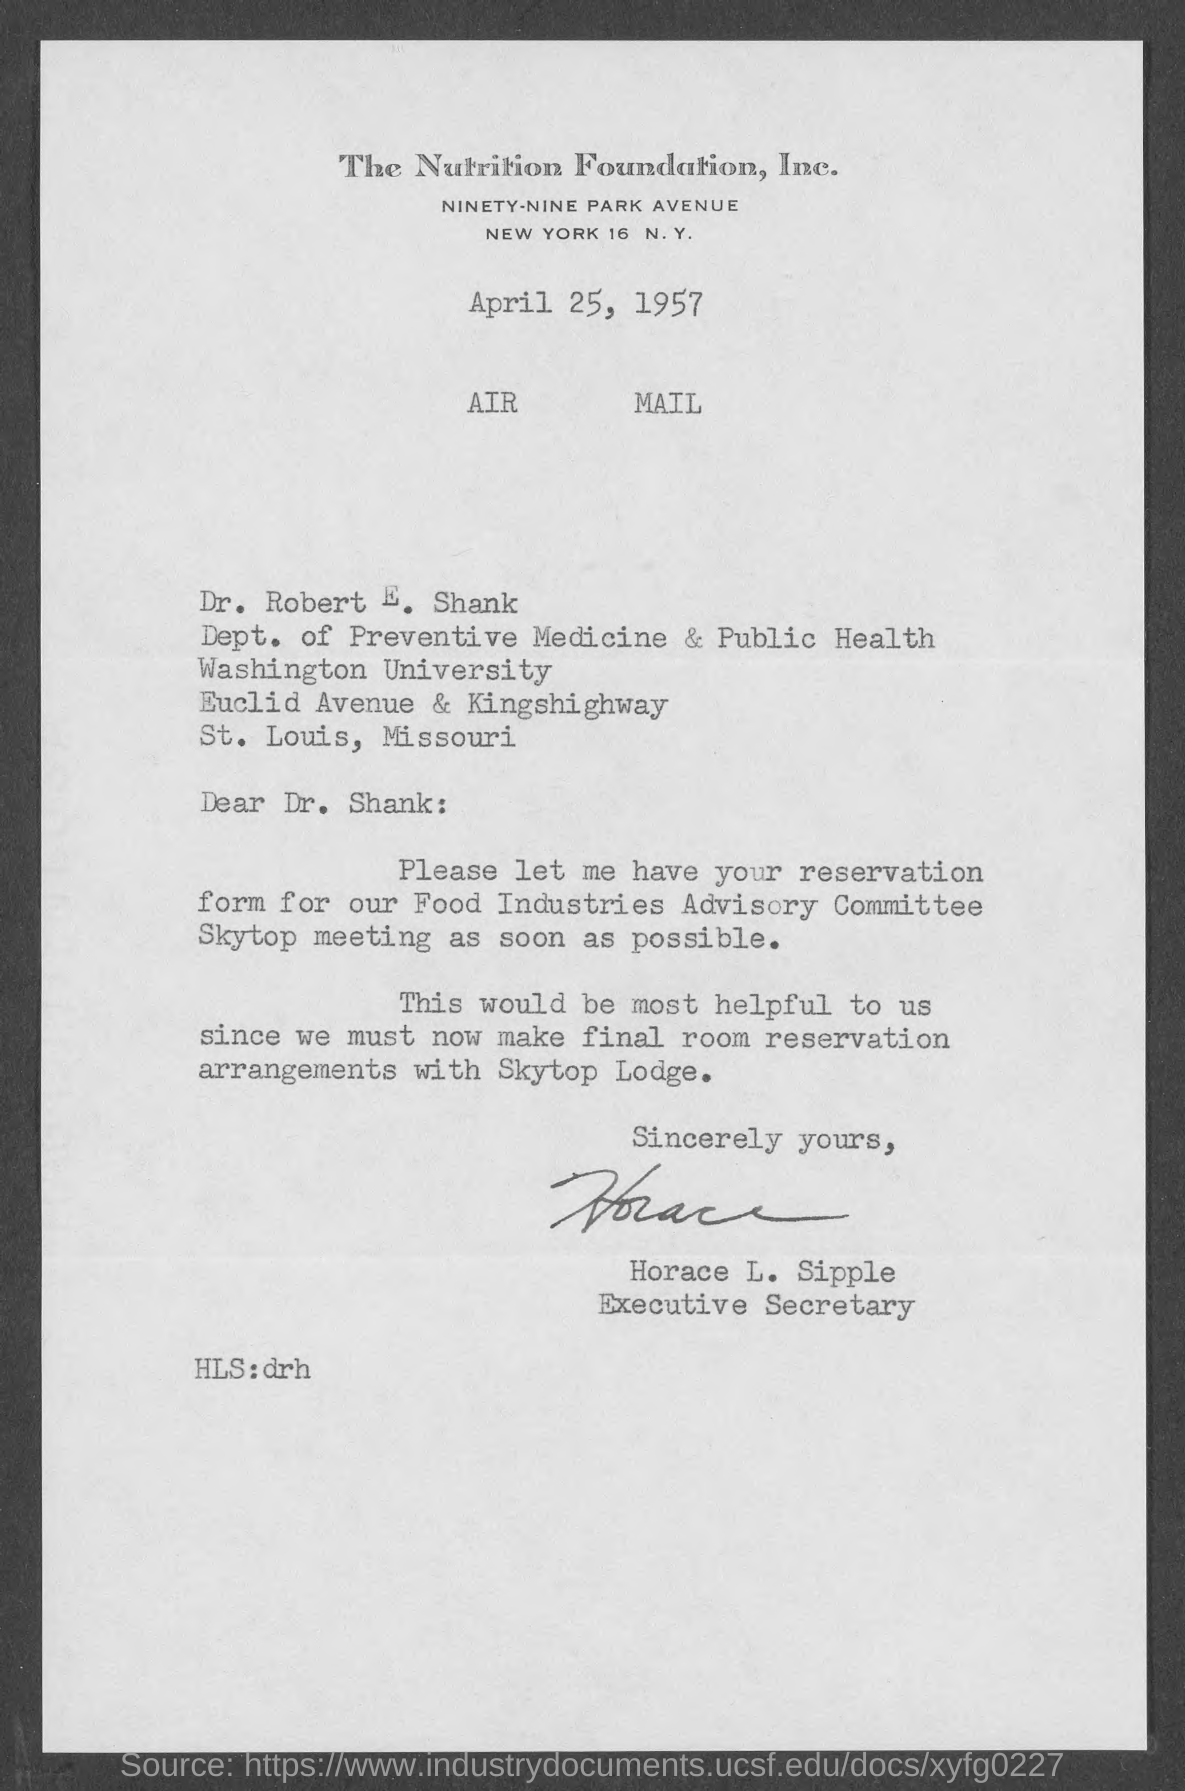Specify some key components in this picture. The Nutrition Foundation, Inc., commonly referred to as "the Company," is a non-profit organization dedicated to promoting public awareness and education about the importance of proper nutrition and its impact on overall health and well-being. Horace L. Sipple is the Executive Secretary. The memorandum is directed to Dr. Robert E. Shank. The document contains the date of April 25, 1957. 